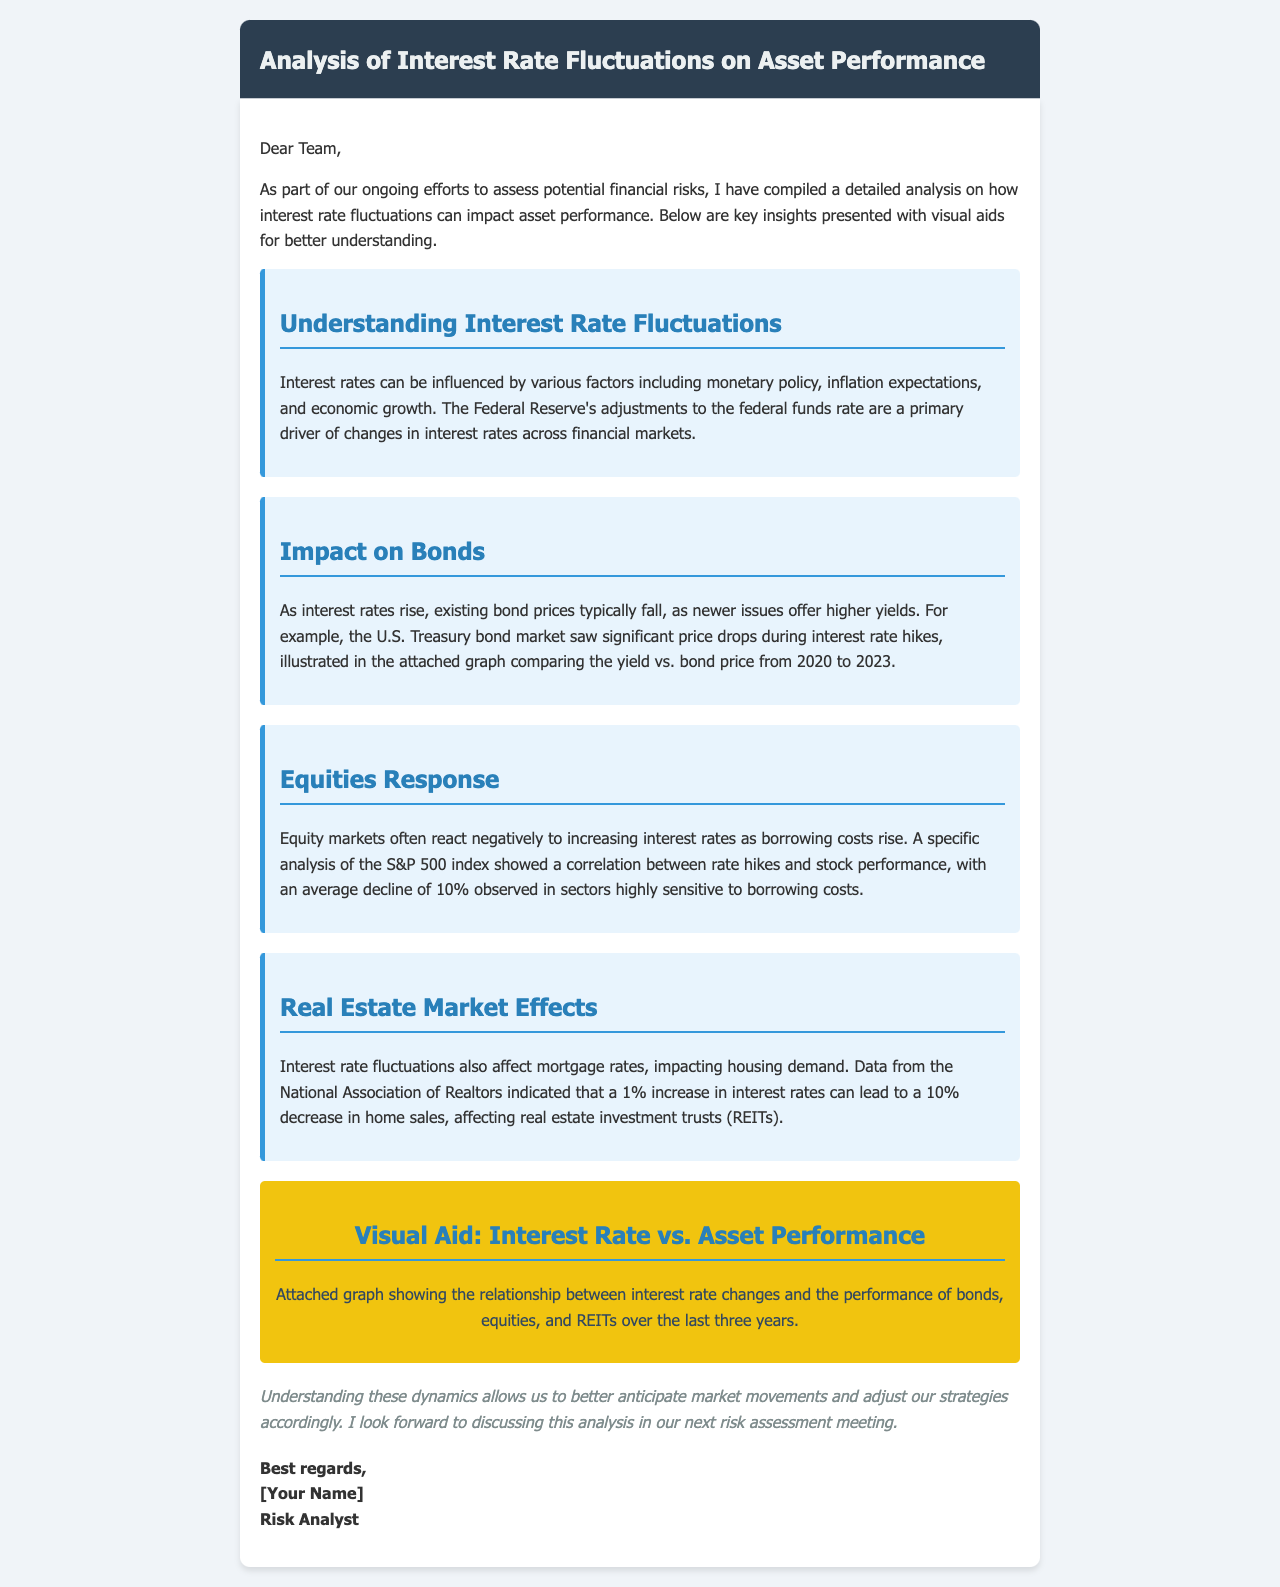what is the main topic of the analysis? The main topic explored in the email is the impact of interest rate fluctuations on asset performance.
Answer: impact of interest rate fluctuations on asset performance who compiled the analysis? The email indicates that the analysis was compiled by a member of the team, specifically identified as a Risk Analyst.
Answer: [Your Name] what is the average decline in the S&P 500 index during interest rate hikes? A specific analysis mentioned in the email notes that the S&P 500 index experienced an average decline of 10%.
Answer: 10% what organization provided data on the impact of interest rates on home sales? The National Association of Realtors provided the data regarding the effect of interest rates on housing demand.
Answer: National Association of Realtors which asset category is negatively impacted by rising interest rates? The email mentions that equity markets often react negatively to rising interest rates due to increased borrowing costs.
Answer: equity markets how much can a 1% increase in interest rates decrease home sales? It is mentioned that a 1% increase in interest rates can lead to a 10% decrease in home sales.
Answer: 10% what type of visual aid is included in the analysis? The email refers to an attached graph that shows the relationship between interest rate changes and the performance of various asset classes.
Answer: attached graph what is the expected outcome of understanding interest rate dynamics? The analysis concludes that understanding these dynamics allows better anticipation of market movements and adjustments in strategies.
Answer: better anticipation of market movements 